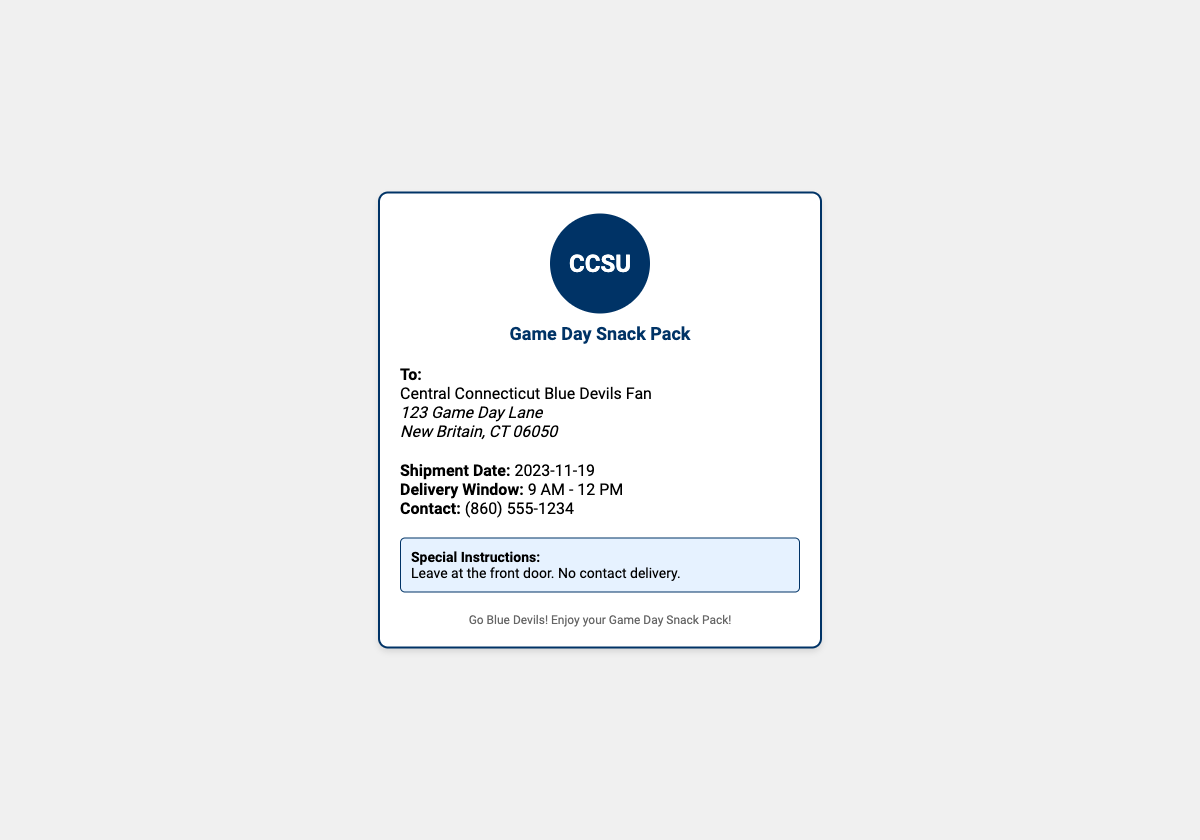What is the shipment date? The shipment date is clearly stated in the details section of the label as 2023-11-19.
Answer: 2023-11-19 What is the delivery window? The delivery window is specified in the details section, indicating when the package will arrive.
Answer: 9 AM - 12 PM Who is the recipient? The recipient is identified at the top of the address section.
Answer: Central Connecticut Blue Devils Fan Where is the shipping address located? The address section contains the full location for the delivery.
Answer: 123 Game Day Lane, New Britain, CT 06050 What are the special instructions for delivery? The special instructions are highlighted in a separate box and provide guidance for the delivery person.
Answer: Leave at the front door. No contact delivery What is the contact number provided? The details section includes a contact number for any inquiries.
Answer: (860) 555-1234 What is the logo shown on the shipping label? The logo is displayed prominently in the header section of the label.
Answer: CCSU What does the footer message say? The footer contains a supportive message for the fans watching the game.
Answer: Go Blue Devils! Enjoy your Game Day Snack Pack! 